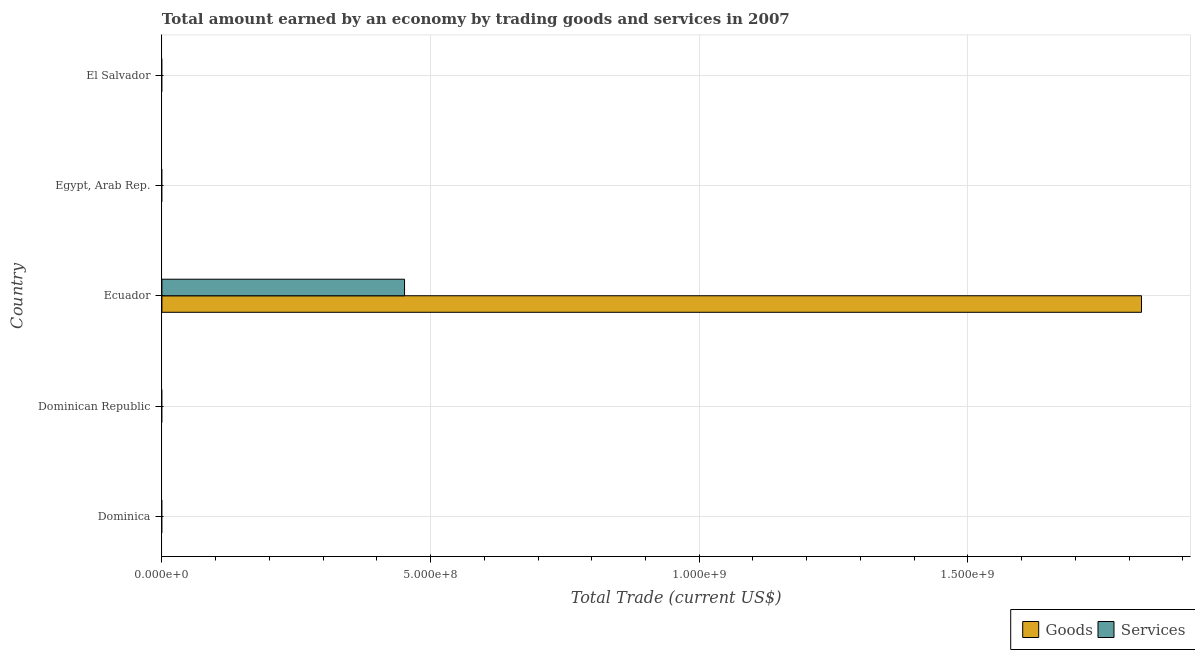Are the number of bars per tick equal to the number of legend labels?
Your answer should be very brief. No. Are the number of bars on each tick of the Y-axis equal?
Offer a very short reply. No. What is the label of the 1st group of bars from the top?
Provide a short and direct response. El Salvador. What is the amount earned by trading goods in Egypt, Arab Rep.?
Ensure brevity in your answer.  0. Across all countries, what is the maximum amount earned by trading services?
Your answer should be very brief. 4.52e+08. Across all countries, what is the minimum amount earned by trading services?
Offer a terse response. 0. In which country was the amount earned by trading goods maximum?
Your response must be concise. Ecuador. What is the total amount earned by trading goods in the graph?
Your response must be concise. 1.82e+09. What is the difference between the amount earned by trading goods in Dominican Republic and the amount earned by trading services in Egypt, Arab Rep.?
Your answer should be compact. 0. What is the average amount earned by trading goods per country?
Keep it short and to the point. 3.65e+08. What is the difference between the amount earned by trading services and amount earned by trading goods in Ecuador?
Give a very brief answer. -1.37e+09. What is the difference between the highest and the lowest amount earned by trading goods?
Your answer should be compact. 1.82e+09. In how many countries, is the amount earned by trading goods greater than the average amount earned by trading goods taken over all countries?
Ensure brevity in your answer.  1. How many countries are there in the graph?
Provide a short and direct response. 5. What is the difference between two consecutive major ticks on the X-axis?
Keep it short and to the point. 5.00e+08. Does the graph contain any zero values?
Offer a very short reply. Yes. Does the graph contain grids?
Provide a short and direct response. Yes. Where does the legend appear in the graph?
Offer a very short reply. Bottom right. How many legend labels are there?
Make the answer very short. 2. What is the title of the graph?
Your response must be concise. Total amount earned by an economy by trading goods and services in 2007. Does "Unregistered firms" appear as one of the legend labels in the graph?
Ensure brevity in your answer.  No. What is the label or title of the X-axis?
Offer a very short reply. Total Trade (current US$). What is the Total Trade (current US$) of Services in Dominica?
Your answer should be compact. 0. What is the Total Trade (current US$) in Goods in Dominican Republic?
Your response must be concise. 0. What is the Total Trade (current US$) of Goods in Ecuador?
Provide a short and direct response. 1.82e+09. What is the Total Trade (current US$) in Services in Ecuador?
Provide a short and direct response. 4.52e+08. What is the Total Trade (current US$) in Goods in Egypt, Arab Rep.?
Offer a terse response. 0. Across all countries, what is the maximum Total Trade (current US$) of Goods?
Offer a very short reply. 1.82e+09. Across all countries, what is the maximum Total Trade (current US$) in Services?
Make the answer very short. 4.52e+08. Across all countries, what is the minimum Total Trade (current US$) in Goods?
Your response must be concise. 0. Across all countries, what is the minimum Total Trade (current US$) of Services?
Ensure brevity in your answer.  0. What is the total Total Trade (current US$) of Goods in the graph?
Provide a succinct answer. 1.82e+09. What is the total Total Trade (current US$) in Services in the graph?
Give a very brief answer. 4.52e+08. What is the average Total Trade (current US$) of Goods per country?
Make the answer very short. 3.65e+08. What is the average Total Trade (current US$) in Services per country?
Keep it short and to the point. 9.03e+07. What is the difference between the Total Trade (current US$) in Goods and Total Trade (current US$) in Services in Ecuador?
Provide a short and direct response. 1.37e+09. What is the difference between the highest and the lowest Total Trade (current US$) of Goods?
Keep it short and to the point. 1.82e+09. What is the difference between the highest and the lowest Total Trade (current US$) in Services?
Provide a succinct answer. 4.52e+08. 